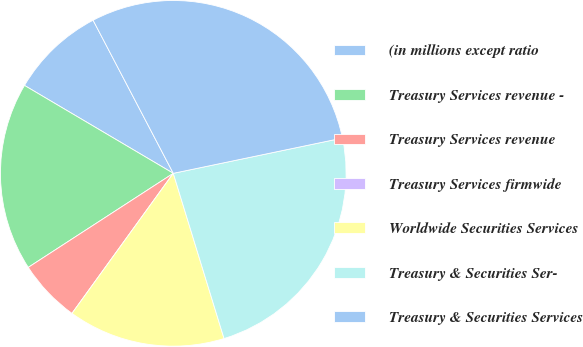Convert chart to OTSL. <chart><loc_0><loc_0><loc_500><loc_500><pie_chart><fcel>(in millions except ratio<fcel>Treasury Services revenue -<fcel>Treasury Services revenue<fcel>Treasury Services firmwide<fcel>Worldwide Securities Services<fcel>Treasury & Securities Ser-<fcel>Treasury & Securities Services<nl><fcel>8.83%<fcel>17.65%<fcel>5.88%<fcel>0.0%<fcel>14.71%<fcel>23.53%<fcel>29.41%<nl></chart> 